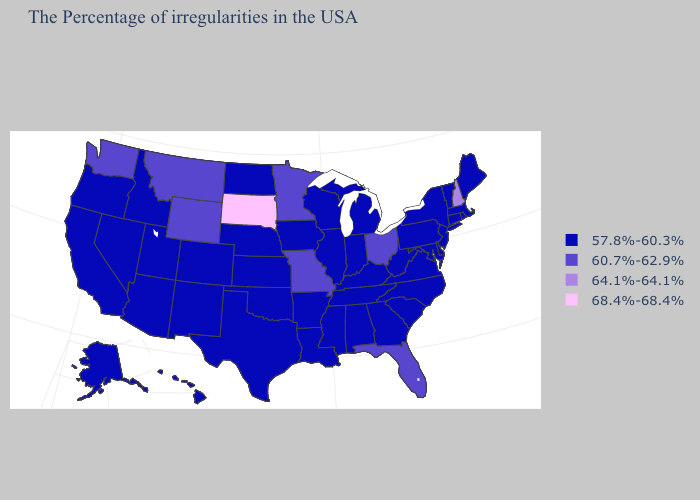Among the states that border Pennsylvania , does New Jersey have the highest value?
Answer briefly. No. Among the states that border Oregon , which have the lowest value?
Be succinct. Idaho, Nevada, California. What is the value of Connecticut?
Give a very brief answer. 57.8%-60.3%. Does Washington have the lowest value in the USA?
Give a very brief answer. No. Name the states that have a value in the range 57.8%-60.3%?
Answer briefly. Maine, Massachusetts, Rhode Island, Vermont, Connecticut, New York, New Jersey, Delaware, Maryland, Pennsylvania, Virginia, North Carolina, South Carolina, West Virginia, Georgia, Michigan, Kentucky, Indiana, Alabama, Tennessee, Wisconsin, Illinois, Mississippi, Louisiana, Arkansas, Iowa, Kansas, Nebraska, Oklahoma, Texas, North Dakota, Colorado, New Mexico, Utah, Arizona, Idaho, Nevada, California, Oregon, Alaska, Hawaii. Does Nebraska have a higher value than Utah?
Be succinct. No. Does Florida have the lowest value in the South?
Keep it brief. No. What is the value of Maryland?
Quick response, please. 57.8%-60.3%. What is the value of Pennsylvania?
Quick response, please. 57.8%-60.3%. What is the value of Washington?
Write a very short answer. 60.7%-62.9%. What is the highest value in the West ?
Write a very short answer. 60.7%-62.9%. Name the states that have a value in the range 64.1%-64.1%?
Give a very brief answer. New Hampshire. Among the states that border Kansas , does Missouri have the highest value?
Short answer required. Yes. Does Florida have the same value as Missouri?
Keep it brief. Yes. 